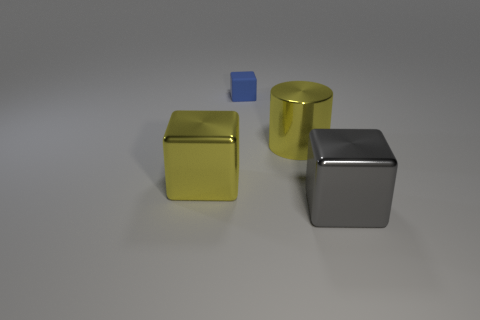Is there another yellow cylinder that has the same material as the large cylinder?
Keep it short and to the point. No. How many rubber things are either tiny blue objects or big yellow cubes?
Provide a succinct answer. 1. There is a large yellow thing that is behind the metal cube that is behind the gray metallic cube; what shape is it?
Your answer should be very brief. Cylinder. Is the number of small blue rubber blocks left of the gray block less than the number of yellow objects?
Your answer should be very brief. Yes. The blue rubber thing is what shape?
Provide a succinct answer. Cube. There is a metallic block that is behind the large gray object; how big is it?
Your answer should be very brief. Large. What color is the metallic cylinder that is the same size as the yellow metallic cube?
Your answer should be very brief. Yellow. Are there any rubber things that have the same color as the tiny block?
Your answer should be very brief. No. Are there fewer small matte blocks that are on the left side of the small blue matte block than big objects that are in front of the big gray thing?
Offer a terse response. No. There is a big thing that is in front of the big metal cylinder and to the right of the tiny matte thing; what is its material?
Give a very brief answer. Metal. 